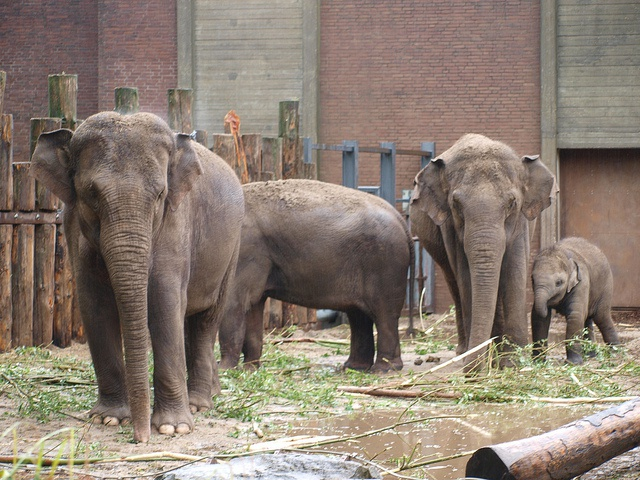Describe the objects in this image and their specific colors. I can see elephant in gray, black, and darkgray tones, elephant in gray and darkgray tones, and elephant in gray, black, and darkgray tones in this image. 